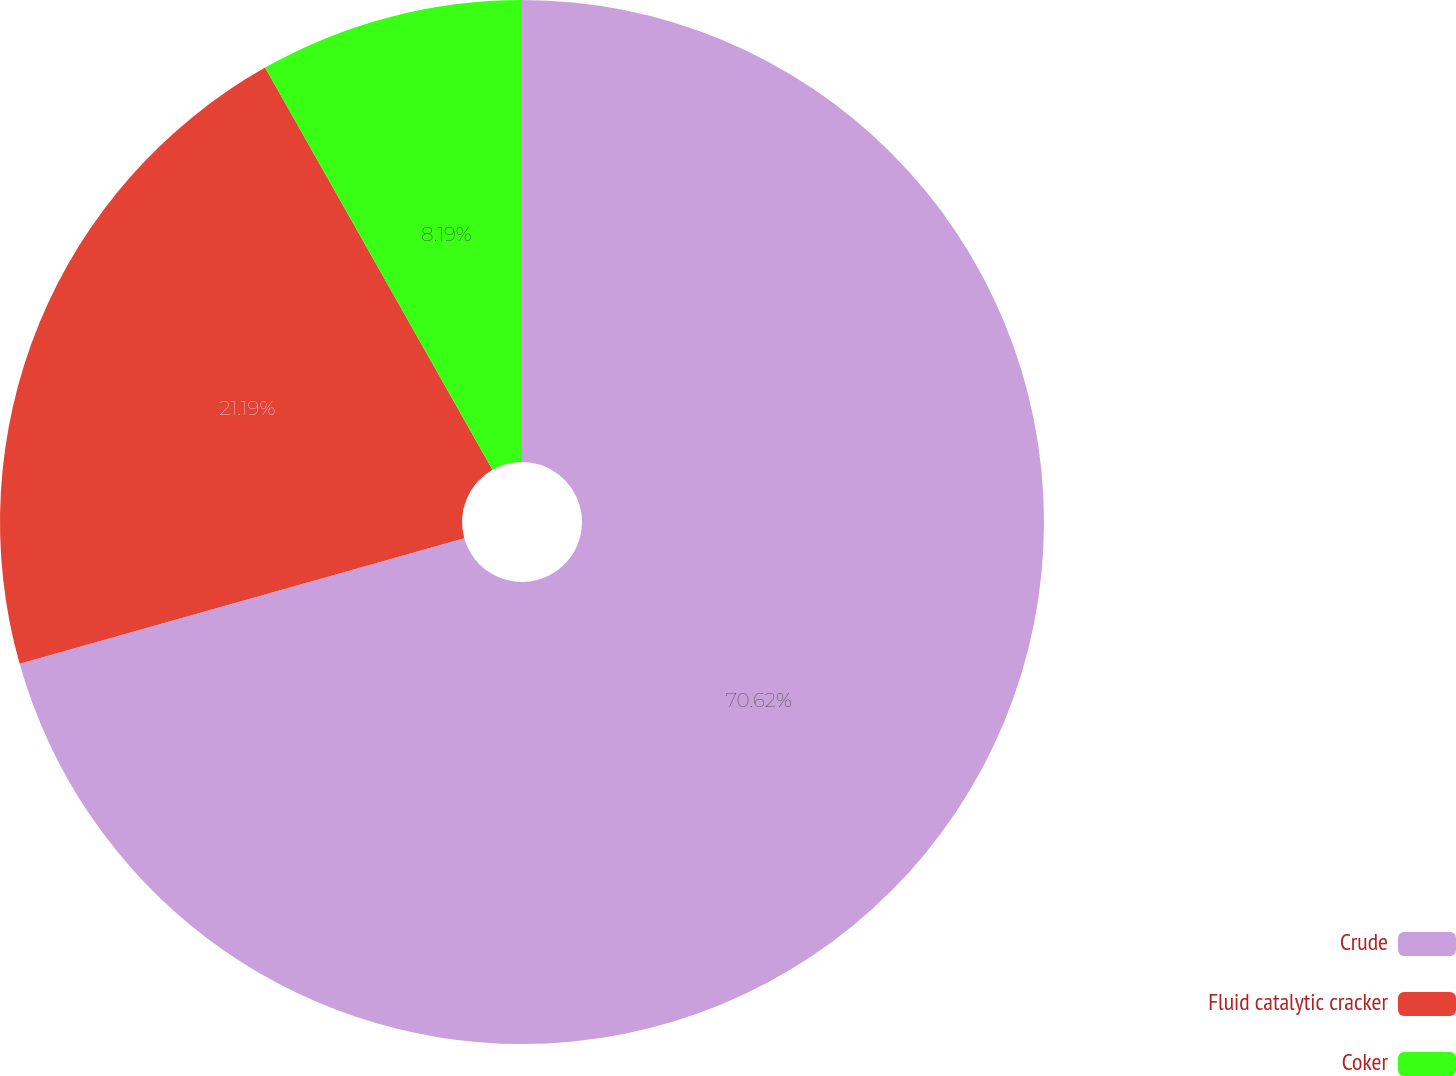Convert chart. <chart><loc_0><loc_0><loc_500><loc_500><pie_chart><fcel>Crude<fcel>Fluid catalytic cracker<fcel>Coker<nl><fcel>70.62%<fcel>21.19%<fcel>8.19%<nl></chart> 